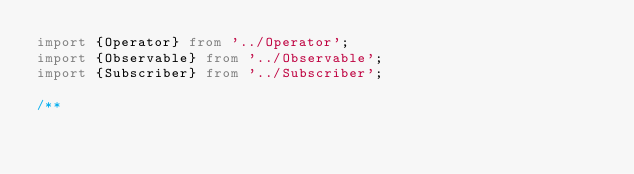<code> <loc_0><loc_0><loc_500><loc_500><_TypeScript_>import {Operator} from '../Operator';
import {Observable} from '../Observable';
import {Subscriber} from '../Subscriber';

/**</code> 